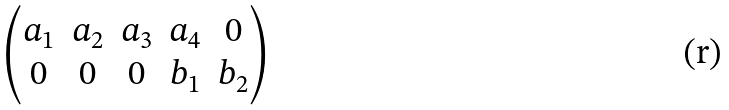Convert formula to latex. <formula><loc_0><loc_0><loc_500><loc_500>\begin{pmatrix} a _ { 1 } & a _ { 2 } & a _ { 3 } & a _ { 4 } & 0 \\ 0 & 0 & 0 & b _ { 1 } & b _ { 2 } \end{pmatrix}</formula> 